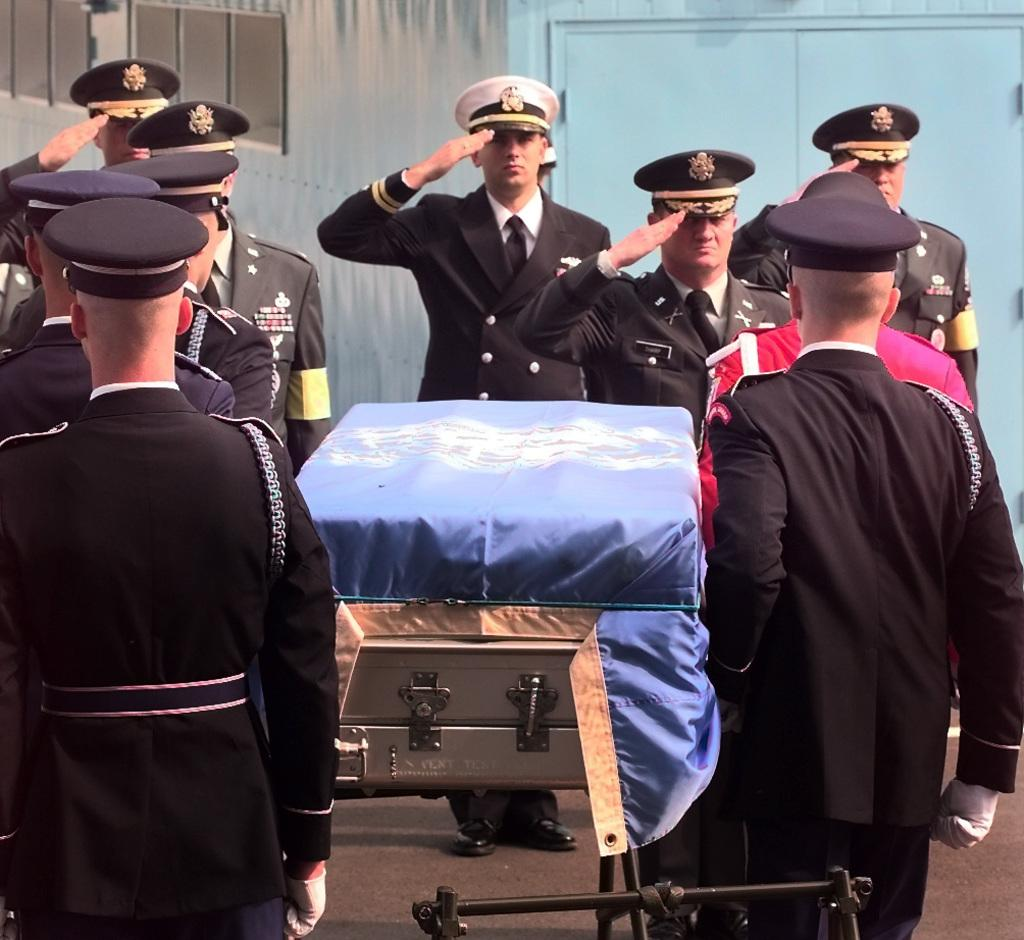What type of people are present in the image? There are officers in the image. What are the officers doing in the image? The officers are paying respect to a deceased officer. What can be seen in the background of the image? There is a wall visible in the background of the image. What type of roof can be seen on the building in the image? There is no roof visible in the image; only a wall is present in the background. What type of jeans are the officers wearing in the image? The provided facts do not mention the officers' clothing, so we cannot determine if they are wearing jeans or any other type of clothing. 